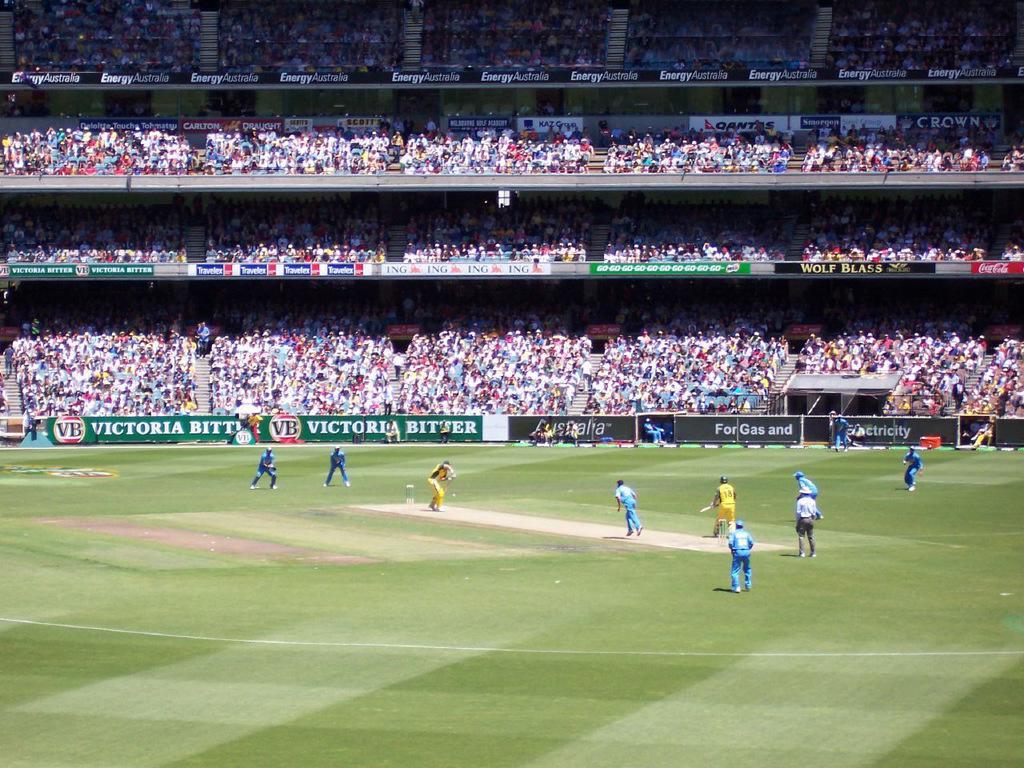Describe this image in one or two sentences. In this picture we can see some people are playing cricket on the ground, posters, steps, some objects and a group of people. 